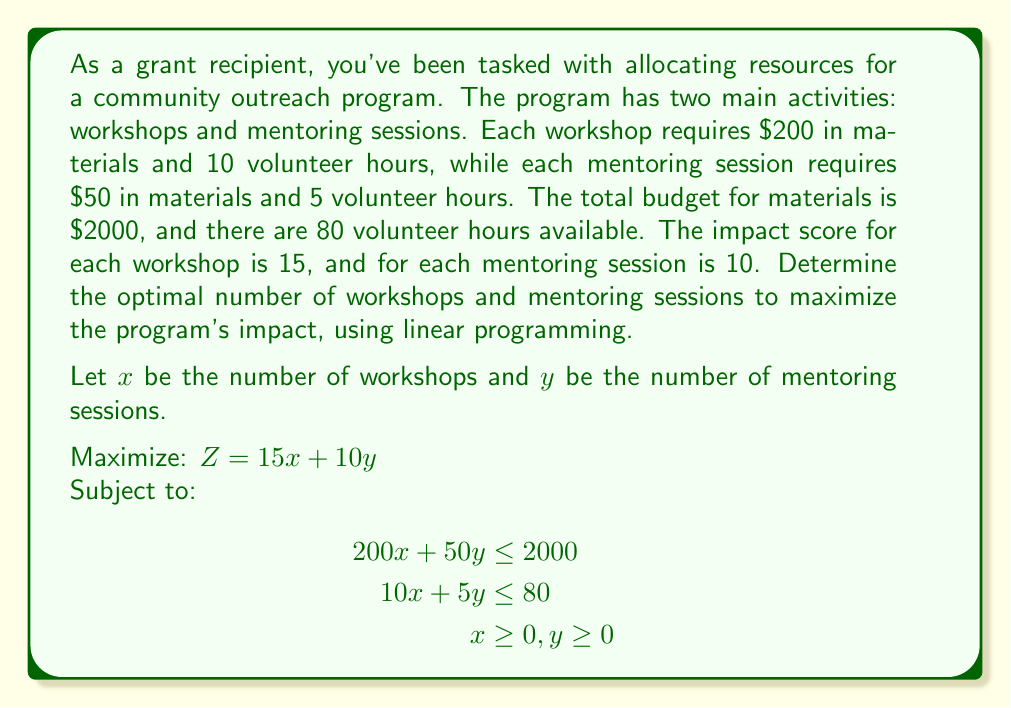Provide a solution to this math problem. To solve this linear programming problem, we'll use the graphical method:

1. Plot the constraints:
   a. $200x + 50y = 2000$ (Budget constraint)
   b. $10x + 5y = 80$ (Volunteer hours constraint)
   c. $x \geq 0, y \geq 0$ (Non-negativity constraints)

2. Identify the feasible region:
   The feasible region is the area that satisfies all constraints.

3. Find the corner points of the feasible region:
   a. (0, 0)
   b. (0, 16) - intersection of $y$-axis and budget constraint
   c. (8, 0) - intersection of $x$-axis and volunteer hours constraint
   d. Intersection of budget and volunteer hours constraints:
      Solve the system of equations:
      $200x + 50y = 2000$
      $10x + 5y = 80$
      
      Multiplying the second equation by 20:
      $200x + 50y = 2000$
      $200x + 100y = 1600$
      
      Subtracting the second from the first:
      $-50y = 400$
      $y = 8$
      
      Substituting back:
      $200x + 50(8) = 2000$
      $200x = 1600$
      $x = 8$
      
      So, the intersection point is (8, 8)

4. Evaluate the objective function at each corner point:
   $Z = 15x + 10y$
   a. (0, 0): $Z = 0$
   b. (0, 16): $Z = 160$
   c. (8, 0): $Z = 120$
   d. (8, 8): $Z = 200$

5. The maximum value of $Z$ occurs at the point (8, 8).

Therefore, the optimal solution is to conduct 8 workshops and 8 mentoring sessions, which will result in a maximum impact score of 200.
Answer: The optimal allocation is 8 workshops and 8 mentoring sessions, resulting in a maximum impact score of 200. 